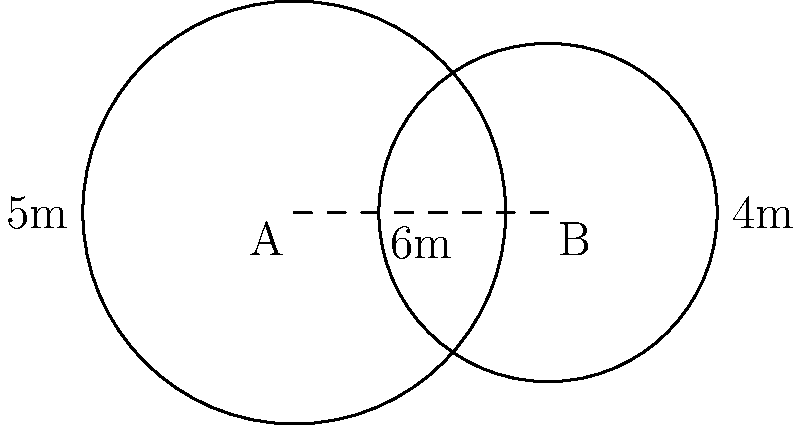On a football practice field, two circular training zones overlap as shown in the diagram. Zone A has a radius of 5 meters, and Zone B has a radius of 4 meters. The centers of the zones are 6 meters apart. Calculate the area of the overlapping region to determine the shared practice space. Round your answer to the nearest square meter. To find the area of overlap between two circles, we'll use the formula for the area of intersection:

$$A = r_1^2 \arccos(\frac{d^2 + r_1^2 - r_2^2}{2dr_1}) + r_2^2 \arccos(\frac{d^2 + r_2^2 - r_1^2}{2dr_2}) - \frac{1}{2}\sqrt{(-d+r_1+r_2)(d+r_1-r_2)(d-r_1+r_2)(d+r_1+r_2)}$$

Where:
$r_1$ = radius of circle 1 (5m)
$r_2$ = radius of circle 2 (4m)
$d$ = distance between centers (6m)

Step 1: Calculate the first term
$$r_1^2 \arccos(\frac{d^2 + r_1^2 - r_2^2}{2dr_1}) = 5^2 \arccos(\frac{6^2 + 5^2 - 4^2}{2 \cdot 6 \cdot 5}) \approx 10.41$$

Step 2: Calculate the second term
$$r_2^2 \arccos(\frac{d^2 + r_2^2 - r_1^2}{2dr_2}) = 4^2 \arccos(\frac{6^2 + 4^2 - 5^2}{2 \cdot 6 \cdot 4}) \approx 4.36$$

Step 3: Calculate the third term
$$\frac{1}{2}\sqrt{(-d+r_1+r_2)(d+r_1-r_2)(d-r_1+r_2)(d+r_1+r_2)} \approx 6.78$$

Step 4: Sum up the terms
$$A = 10.41 + 4.36 - 6.78 \approx 7.99$$

Step 5: Round to the nearest square meter
$$A \approx 8 \text{ m}^2$$
Answer: 8 m² 